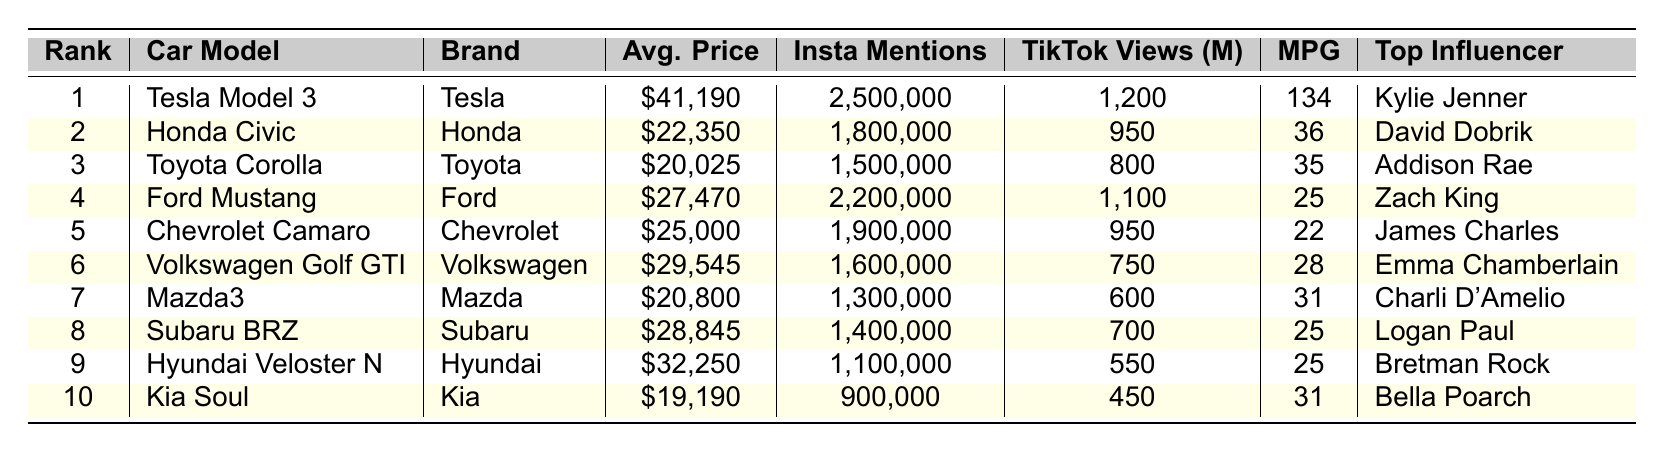What car model is the most popular among Gen Z? The first row of the table indicates that the most popular car model ranked 1 is the Tesla Model 3.
Answer: Tesla Model 3 Who owns the Ford Mustang among the top influencers? The table indicates that the Ford Mustang is owned by Zach King as listed in the "Top Influencer Owner" column.
Answer: Zach King What is the average price of the top three car models? The prices of the top three models are $41,190 (Tesla Model 3), $22,350 (Honda Civic), and $20,025 (Toyota Corolla). Summing them gives $41,190 + $22,350 + $20,025 = $83,565. Dividing by 3 gives an average price of $27,855.
Answer: $27,855 How many Instagram mentions does the Toyota Corolla have? The table lists the number of Instagram mentions for the Toyota Corolla in its respective row, which is 1,500,000.
Answer: 1,500,000 Is the Subaru BRZ more fuel-efficient than the Hyundai Veloster N? The MPG value for Subaru BRZ is 25 and for Hyundai Veloster N is also 25. Since they are equal, it can be concluded they have the same fuel efficiency.
Answer: No Which car has the highest TikTok views, and what are those views? By looking at the TikTok views column, the Tesla Model 3 has the highest views at 1,200 million, as listed in its row.
Answer: 1,200 million What is the difference in average price between the most and least expensive car models on this list? The most expensive is the Tesla Model 3 at $41,190, and the least expensive is the Kia Soul at $19,190. The difference is $41,190 - $19,190 = $22,000.
Answer: $22,000 Calculate the total Instagram mentions of the top two car models. The Instagram mentions for the top two models are 2,500,000 (Tesla Model 3) and 1,800,000 (Honda Civic). Adding these gives 2,500,000 + 1,800,000 = 4,300,000.
Answer: 4,300,000 Which brand has the lowest fuel efficiency among the top ten? The table shows that the Chevrolet Camaro has the lowest MPG value of 22. Thus, Chevrolet is the brand with the lowest fuel efficiency.
Answer: Chevrolet Does the Mazda3 have more TikTok views than the Kia Soul? The TikTok views for Mazda3 is 600 million and for Kia Soul is 450 million. Since 600 is greater than 450, the statement is true.
Answer: Yes 